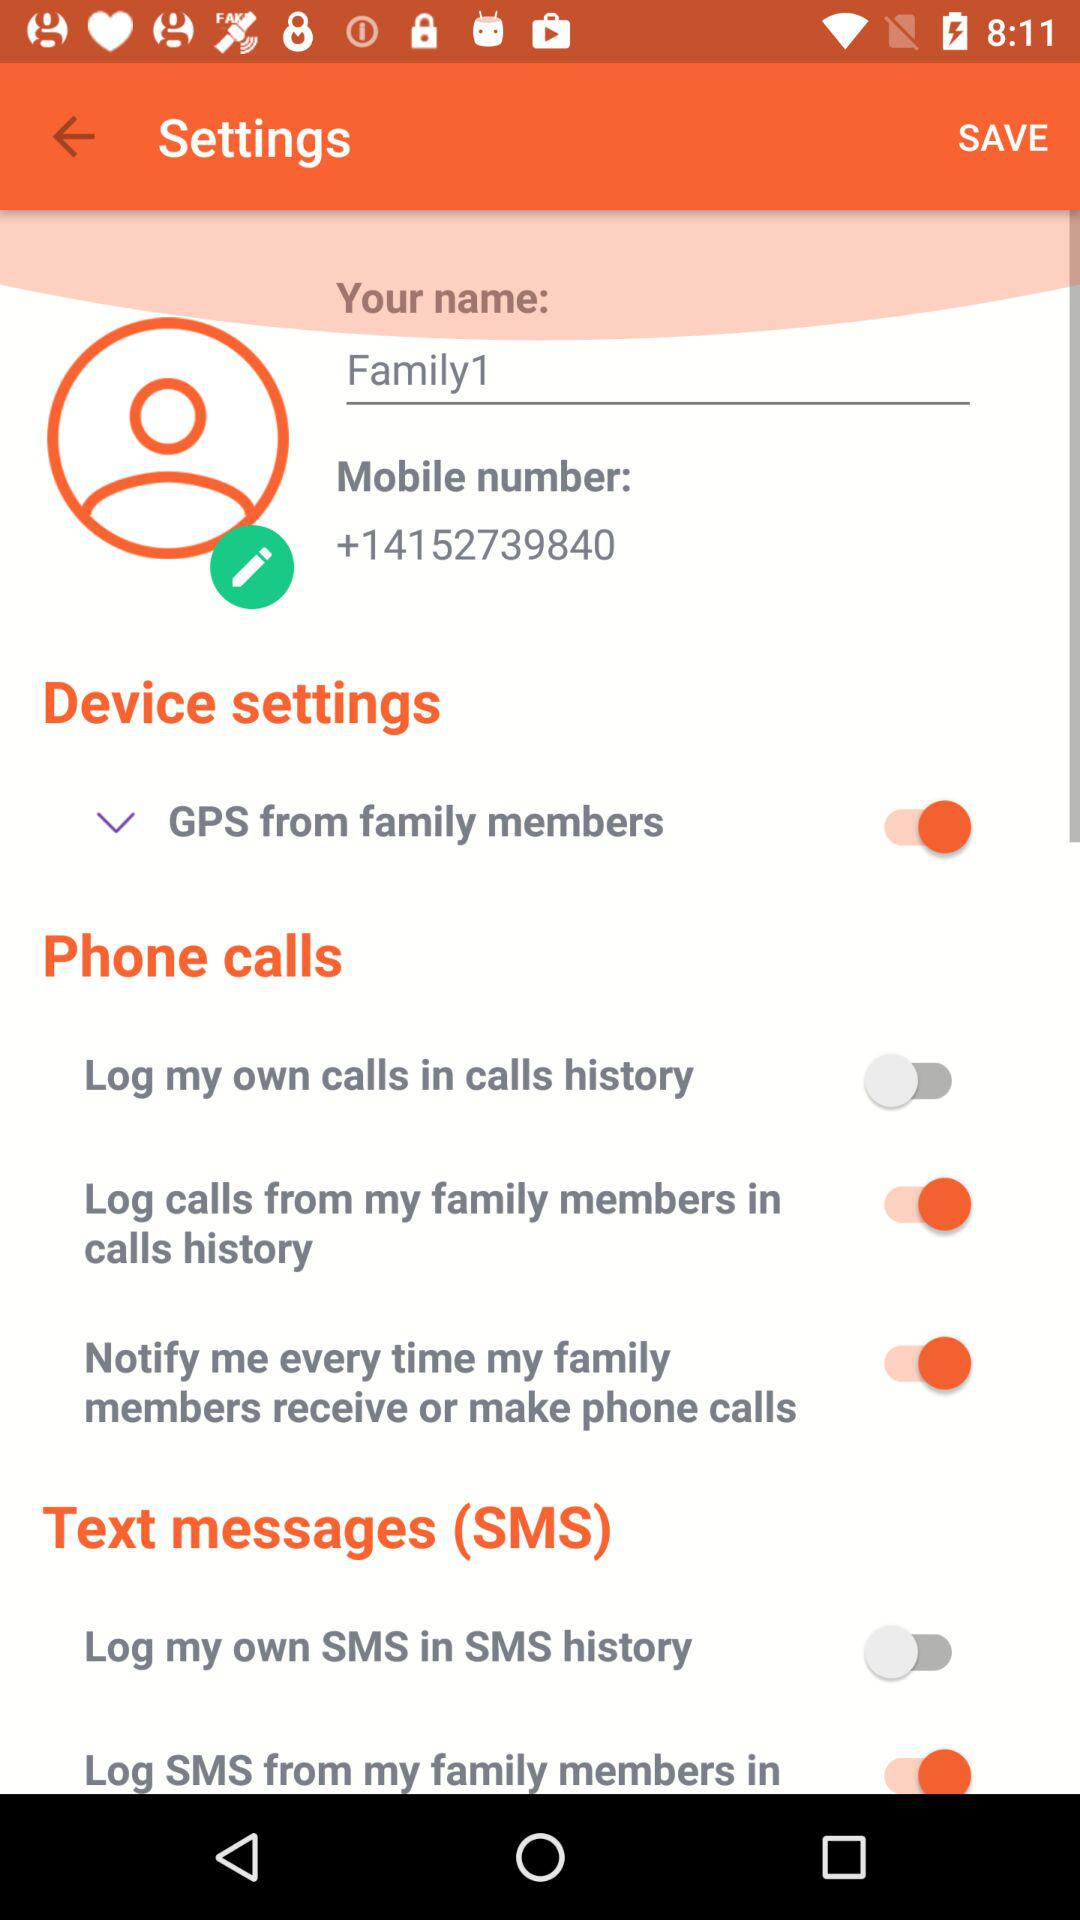What is the status of "Log my own SMS in SMS history"? The status of "Log my own SMS in SMS history" is "off". 